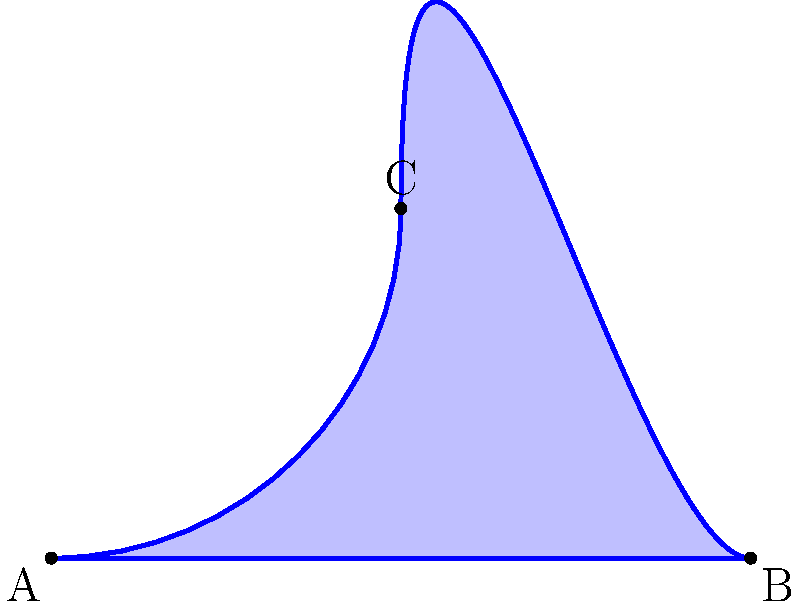Hey buddy, remember that crazy non-Euclidean end zone we had in our championship game? Let's calculate its area! The end zone is shaped like a curved triangle ABC on a warped field. The curved side AC follows the equation $y = \sin(\frac{\pi x}{2})$ from $x=0$ to $x=2$. What's the area of this non-Euclidean end zone? Alright, let's break this down like we used to break down plays:

1) In non-Euclidean geometry on a warped field, we need to use calculus to find the area.

2) The area under a curve is given by the definite integral:

   $$A = \int_0^2 \sin(\frac{\pi x}{2}) dx$$

3) To solve this, we use the substitution method:
   Let $u = \frac{\pi x}{2}$, then $du = \frac{\pi}{2} dx$
   When $x = 0$, $u = 0$; when $x = 2$, $u = \pi$

4) Rewriting the integral:

   $$A = \frac{2}{\pi} \int_0^{\pi} \sin(u) du$$

5) We know that $\int \sin(u) du = -\cos(u) + C$

6) Applying the limits:

   $$A = \frac{2}{\pi} [-\cos(u)]_0^{\pi} = \frac{2}{\pi} [-\cos(\pi) - (-\cos(0))]$$

7) Simplify:
   
   $$A = \frac{2}{\pi} [1 - (-1)] = \frac{4}{\pi}$$

Therefore, the area of our non-Euclidean end zone is $\frac{4}{\pi}$ square units.
Answer: $\frac{4}{\pi}$ square units 